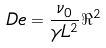Convert formula to latex. <formula><loc_0><loc_0><loc_500><loc_500>\ D e = \frac { \nu _ { 0 } } { \gamma L ^ { 2 } } \Re ^ { 2 }</formula> 